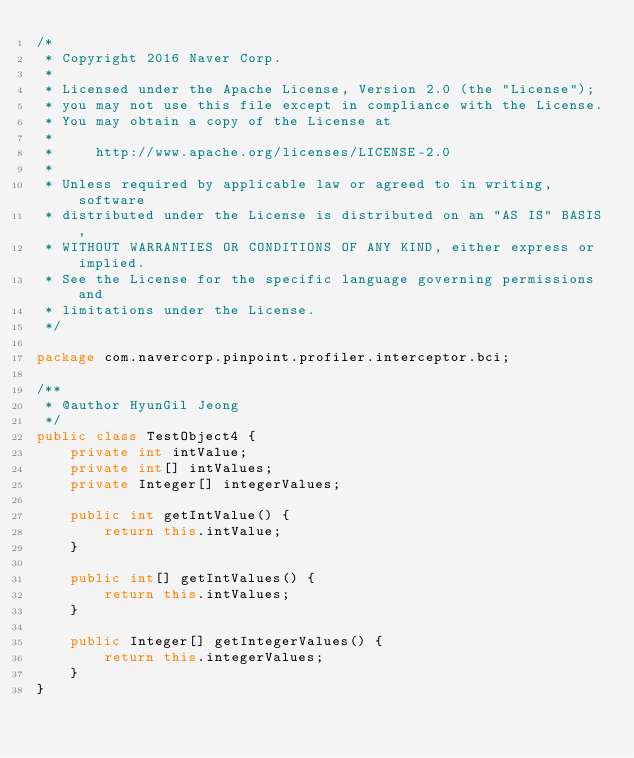<code> <loc_0><loc_0><loc_500><loc_500><_Java_>/*
 * Copyright 2016 Naver Corp.
 *
 * Licensed under the Apache License, Version 2.0 (the "License");
 * you may not use this file except in compliance with the License.
 * You may obtain a copy of the License at
 *
 *     http://www.apache.org/licenses/LICENSE-2.0
 *
 * Unless required by applicable law or agreed to in writing, software
 * distributed under the License is distributed on an "AS IS" BASIS,
 * WITHOUT WARRANTIES OR CONDITIONS OF ANY KIND, either express or implied.
 * See the License for the specific language governing permissions and
 * limitations under the License.
 */

package com.navercorp.pinpoint.profiler.interceptor.bci;

/**
 * @author HyunGil Jeong
 */
public class TestObject4 {
    private int intValue;
    private int[] intValues;
    private Integer[] integerValues;

    public int getIntValue() {
        return this.intValue;
    }

    public int[] getIntValues() {
        return this.intValues;
    }

    public Integer[] getIntegerValues() {
        return this.integerValues;
    }
}
</code> 